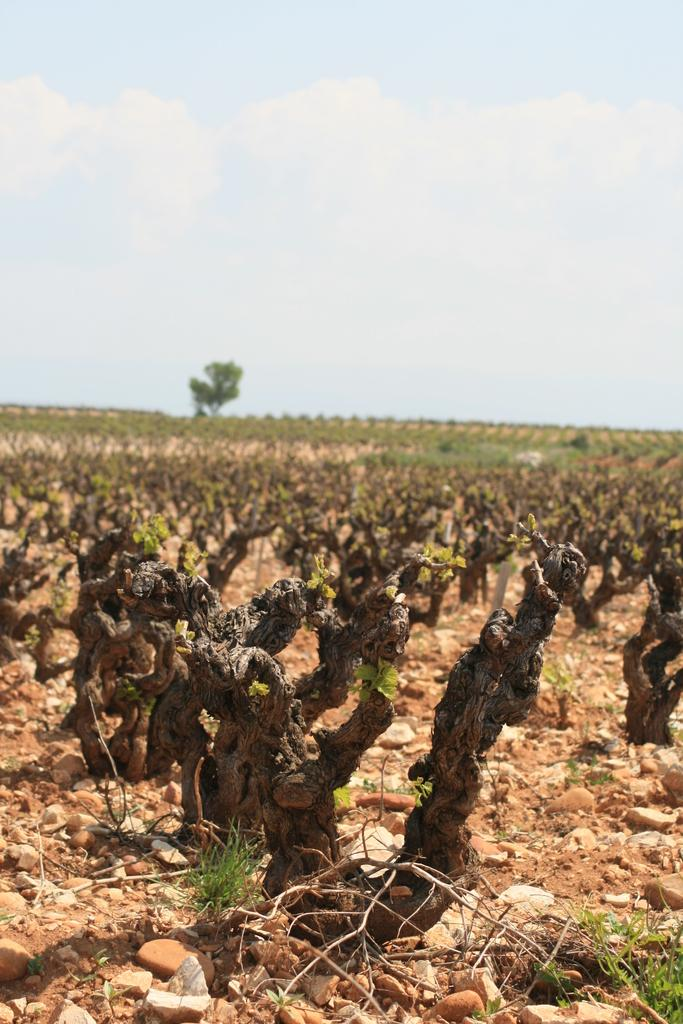What type of surface is visible in the image? There is ground in the image. What objects can be seen on the ground? There are stones in the image. What type of vegetation is present in the image? There is grass, plants, and a tree in the image. What can be seen in the background of the image? The sky is visible in the background of the image. What is the condition of the sky in the image? There are clouds in the sky. What type of bread can be seen hanging from the tree in the image? There is no bread present in the image; it features a tree with no hanging objects. 